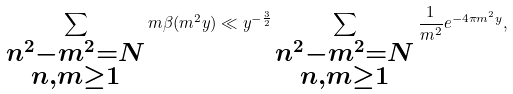<formula> <loc_0><loc_0><loc_500><loc_500>\sum _ { \substack { n ^ { 2 } - m ^ { 2 } = N \\ n , m \geq 1 } } m \beta ( m ^ { 2 } y ) \ll y ^ { - \frac { 3 } { 2 } } \sum _ { \substack { n ^ { 2 } - m ^ { 2 } = N \\ n , m \geq 1 } } \frac { 1 } { m ^ { 2 } } e ^ { - 4 \pi m ^ { 2 } y } ,</formula> 